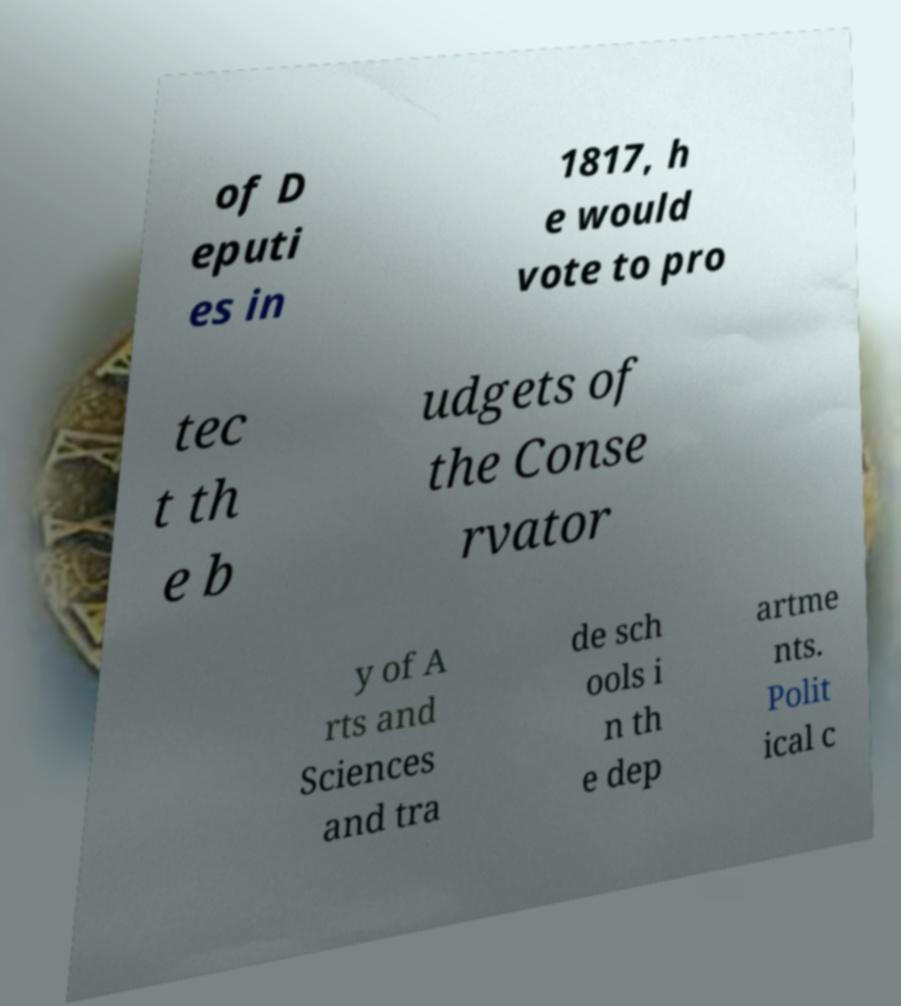I need the written content from this picture converted into text. Can you do that? of D eputi es in 1817, h e would vote to pro tec t th e b udgets of the Conse rvator y of A rts and Sciences and tra de sch ools i n th e dep artme nts. Polit ical c 